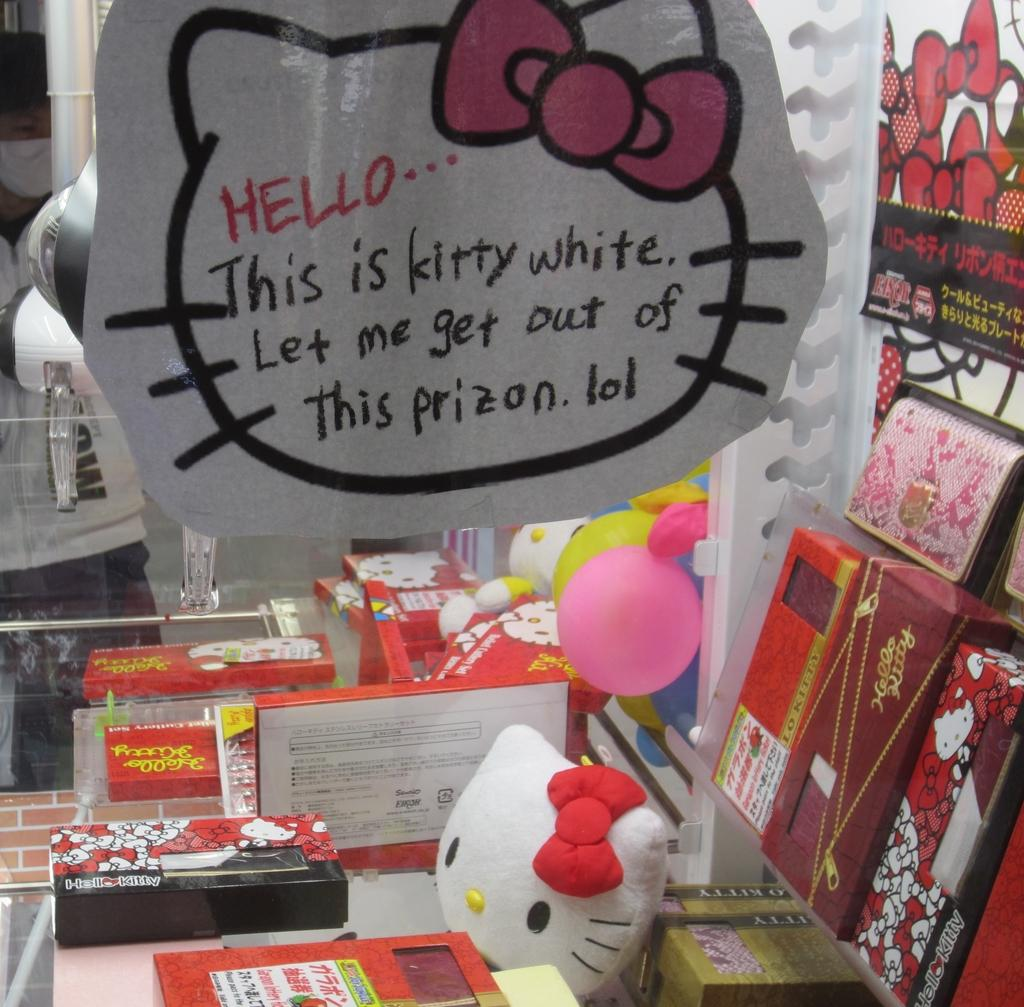<image>
Create a compact narrative representing the image presented. In the window of a shop is a message from Hello Kitty. 